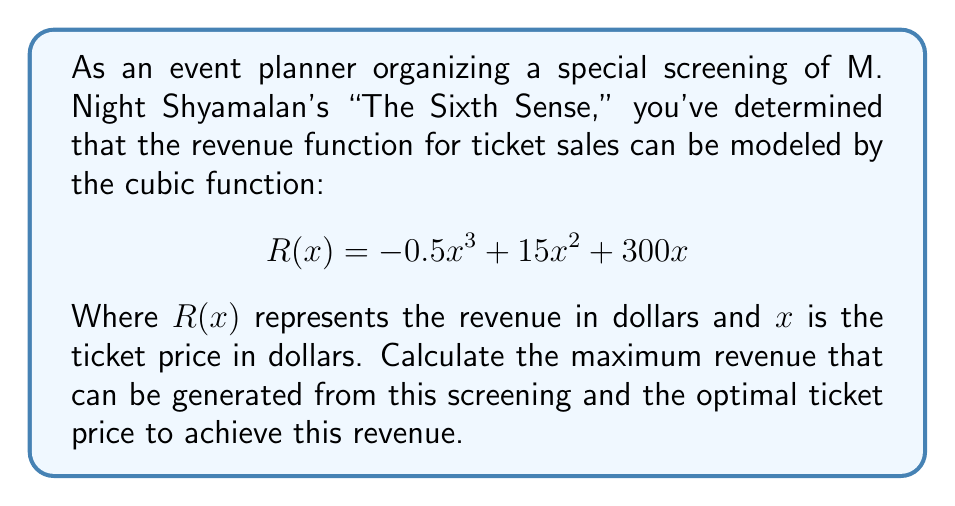Give your solution to this math problem. To find the maximum revenue and optimal ticket price, we need to follow these steps:

1) The maximum revenue will occur at a critical point of the revenue function. To find critical points, we need to find where the derivative of $R(x)$ equals zero.

2) Let's find the derivative of $R(x)$:
   $$R'(x) = -1.5x^2 + 30x + 300$$

3) Set $R'(x) = 0$ and solve for $x$:
   $$-1.5x^2 + 30x + 300 = 0$$

4) This is a quadratic equation. We can solve it using the quadratic formula:
   $$x = \frac{-b \pm \sqrt{b^2 - 4ac}}{2a}$$
   
   Where $a = -1.5$, $b = 30$, and $c = 300$

5) Plugging in these values:
   $$x = \frac{-30 \pm \sqrt{30^2 - 4(-1.5)(300)}}{2(-1.5)}$$
   $$= \frac{-30 \pm \sqrt{900 + 1800}}{-3}$$
   $$= \frac{-30 \pm \sqrt{2700}}{-3}$$
   $$= \frac{-30 \pm 51.96}{-3}$$

6) This gives us two solutions:
   $$x_1 = \frac{-30 + 51.96}{-3} \approx 7.32$$
   $$x_2 = \frac{-30 - 51.96}{-3} \approx 27.32$$

7) To determine which of these gives the maximum revenue, we can check the second derivative:
   $$R''(x) = -3x + 30$$
   
   At $x = 7.32$, $R''(7.32) = 8.04 > 0$, indicating a local minimum.
   At $x = 27.32$, $R''(27.32) = -51.96 < 0$, indicating a local maximum.

8) Therefore, the optimal ticket price is $27.32.

9) To find the maximum revenue, we plug this value back into our original function:
   $$R(27.32) = -0.5(27.32)^3 + 15(27.32)^2 + 300(27.32)$$
   $$\approx 6867.71$$

Thus, the maximum revenue is approximately $6,867.71.
Answer: The maximum revenue that can be generated is approximately $6,867.71, which occurs at the optimal ticket price of $27.32. 